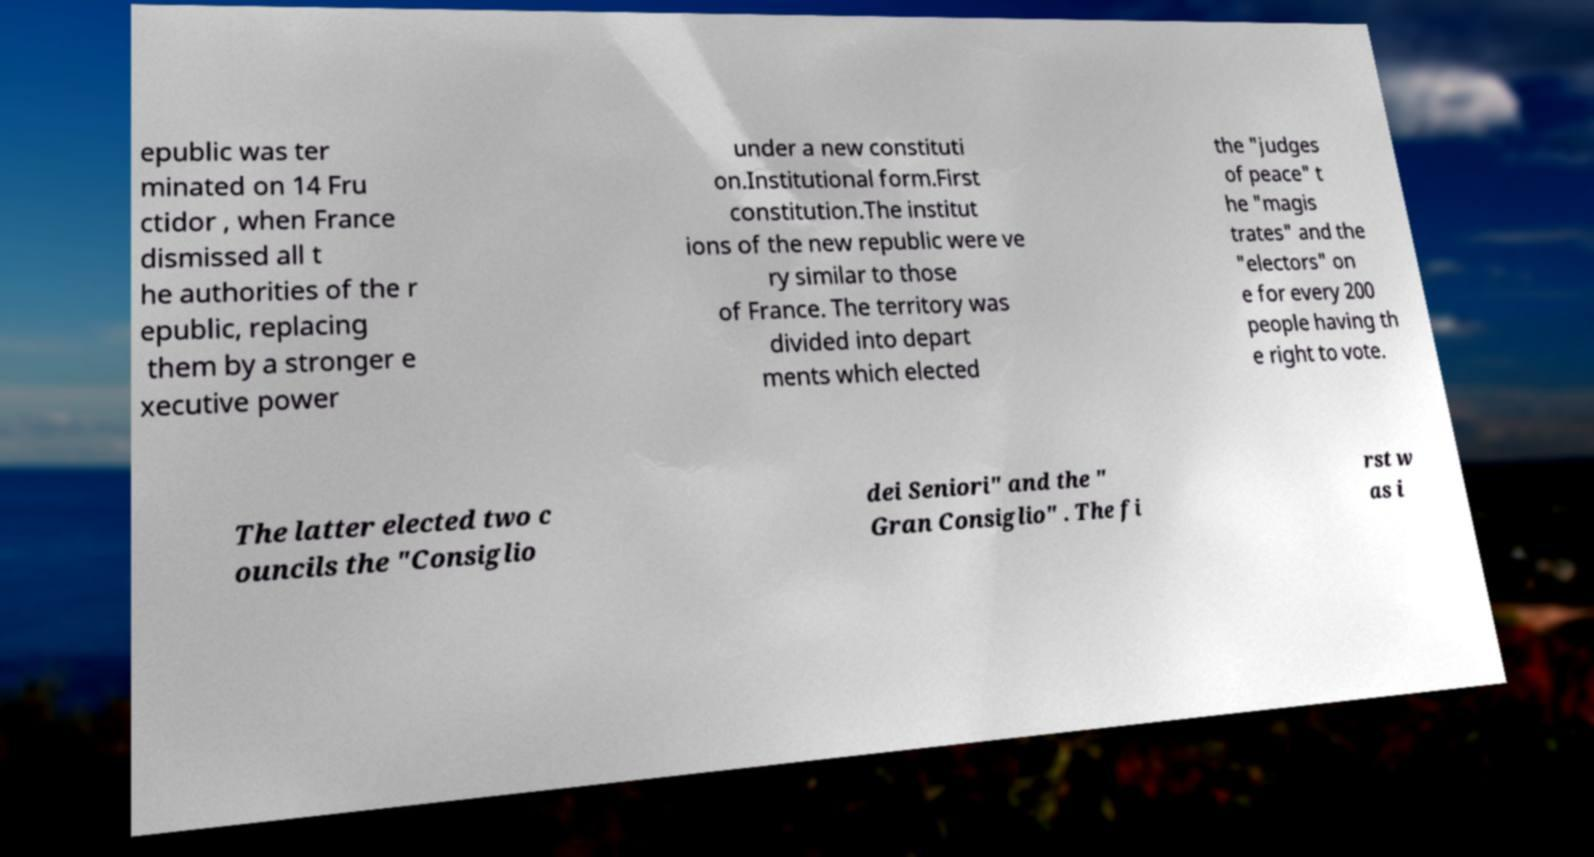There's text embedded in this image that I need extracted. Can you transcribe it verbatim? epublic was ter minated on 14 Fru ctidor , when France dismissed all t he authorities of the r epublic, replacing them by a stronger e xecutive power under a new constituti on.Institutional form.First constitution.The institut ions of the new republic were ve ry similar to those of France. The territory was divided into depart ments which elected the "judges of peace" t he "magis trates" and the "electors" on e for every 200 people having th e right to vote. The latter elected two c ouncils the "Consiglio dei Seniori" and the " Gran Consiglio" . The fi rst w as i 